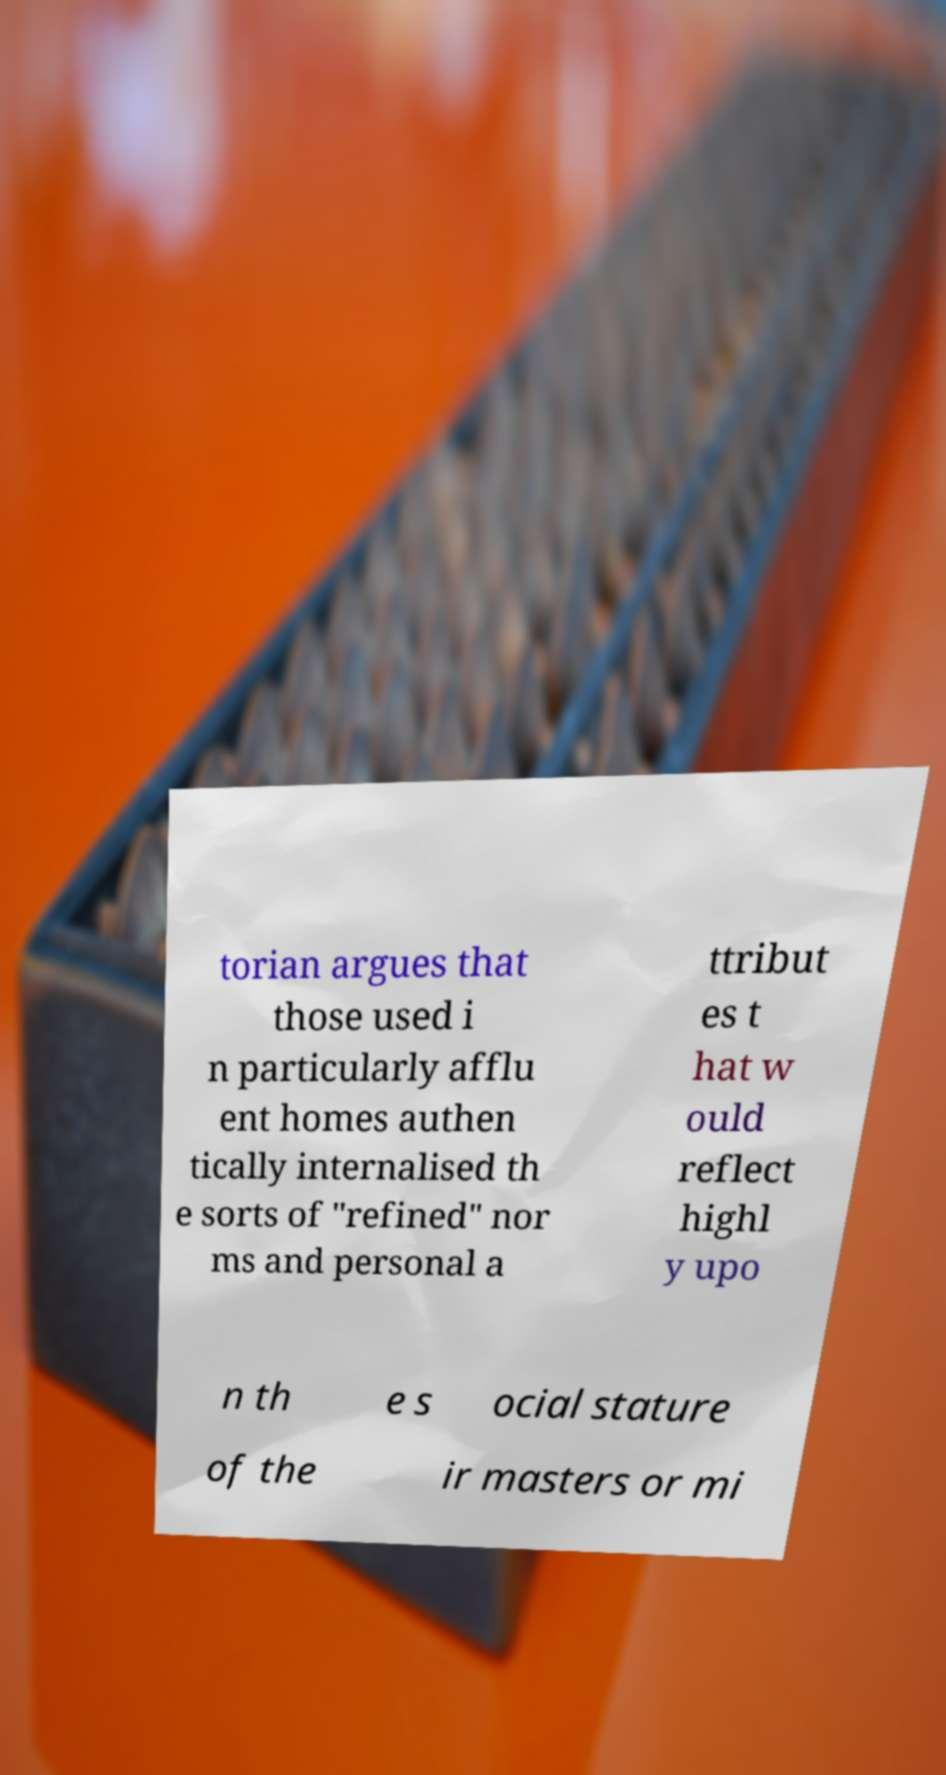Please identify and transcribe the text found in this image. torian argues that those used i n particularly afflu ent homes authen tically internalised th e sorts of "refined" nor ms and personal a ttribut es t hat w ould reflect highl y upo n th e s ocial stature of the ir masters or mi 